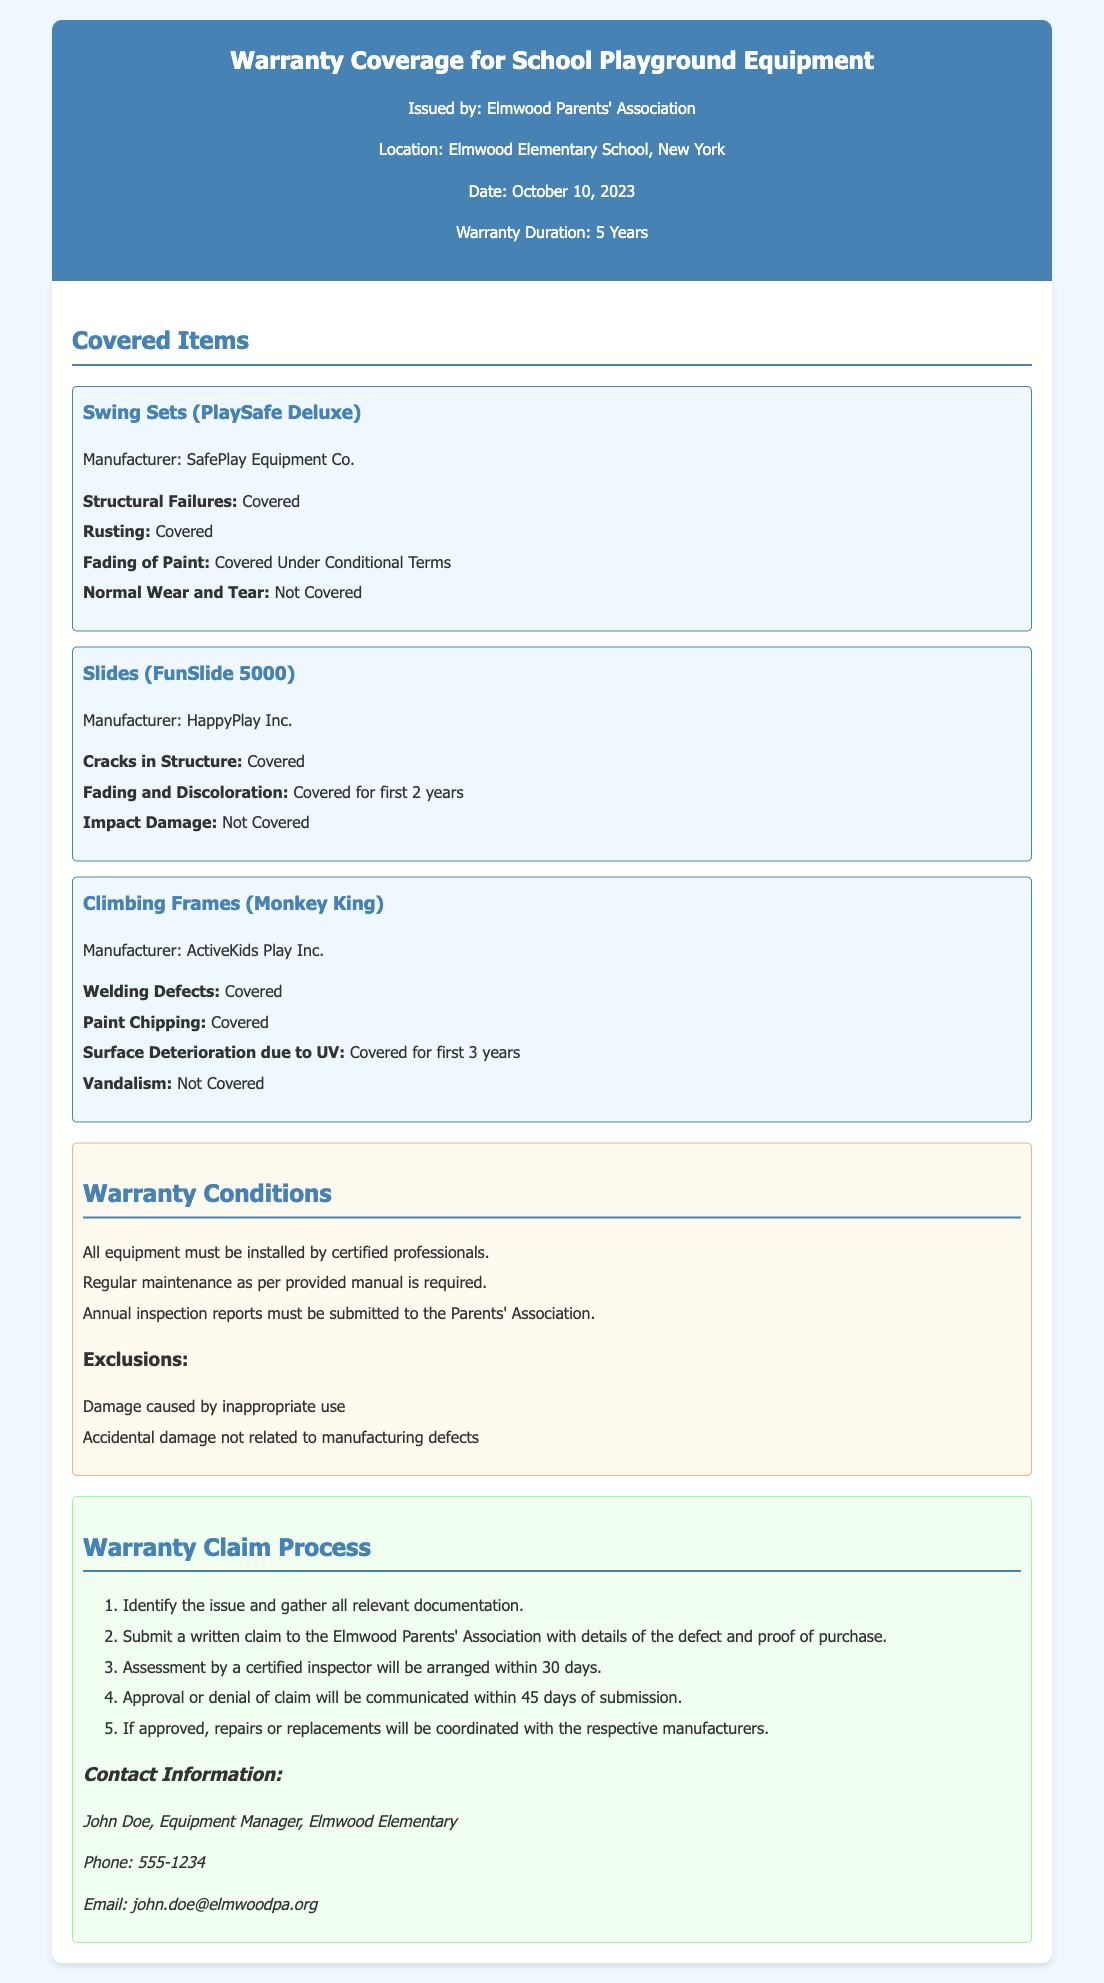what is the warranty duration? The duration of the warranty for the school playground equipment is stated in the document as 5 years.
Answer: 5 Years who issued the warranty? The document specifies that the warranty is issued by the Elmwood Parents' Association.
Answer: Elmwood Parents' Association what item is covered for structural failures? The document lists "Swing Sets (PlaySafe Deluxe)" as covered for structural failures.
Answer: Swing Sets (PlaySafe Deluxe) which manufacturer produces the slides covered under the warranty? The manufacturer's name for the slides is provided in the document as HappyPlay Inc.
Answer: HappyPlay Inc how long is fading and discoloration covered for slides? The document mentions that fading and discoloration for slides is covered for the first 2 years.
Answer: first 2 years what is a requirement for the warranty regarding equipment installation? The document requires that all equipment must be installed by certified professionals to maintain warranty coverage.
Answer: Installed by certified professionals what is the first step in the warranty claim process? The warranty claim process begins with identifying the issue and gathering all relevant documentation.
Answer: Identify the issue and gather all relevant documentation which type of damage is explicitly not covered under the warranty? The document states that damage caused by inappropriate use is one of the exclusions.
Answer: Inappropriate use who is the contact person for warranty questions? The contact person listed for warranty questions is John Doe.
Answer: John Doe 